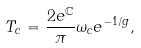Convert formula to latex. <formula><loc_0><loc_0><loc_500><loc_500>T _ { c } = \frac { 2 e ^ { \mathbb { C } } } { \pi } \omega _ { c } e ^ { - 1 / g } ,</formula> 